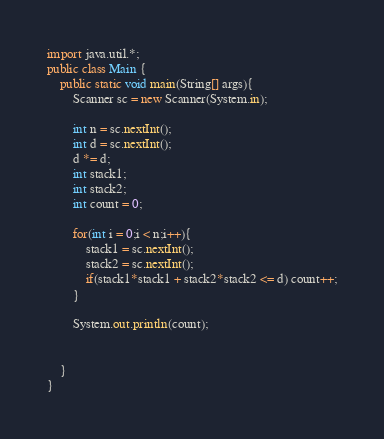Convert code to text. <code><loc_0><loc_0><loc_500><loc_500><_Java_>import java.util.*;
public class Main {
	public static void main(String[] args){
		Scanner sc = new Scanner(System.in);
		
		int n = sc.nextInt();
      	int d = sc.nextInt();
      	d *= d;
      	int stack1;
      	int stack2;
      	int count = 0;
      	
      	for(int i = 0;i < n;i++){
        	stack1 = sc.nextInt();
          	stack2 = sc.nextInt();
          	if(stack1*stack1 + stack2*stack2 <= d) count++;
        }
      
        System.out.println(count);
            	
        
	}
}</code> 